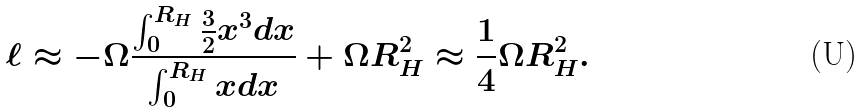Convert formula to latex. <formula><loc_0><loc_0><loc_500><loc_500>\ell \approx - \Omega \frac { \int ^ { R _ { H } } _ { 0 } \frac { 3 } { 2 } x ^ { 3 } d x } { \int ^ { R _ { H } } _ { 0 } x d x } + \Omega R _ { H } ^ { 2 } \approx \frac { 1 } { 4 } \Omega R _ { H } ^ { 2 } .</formula> 